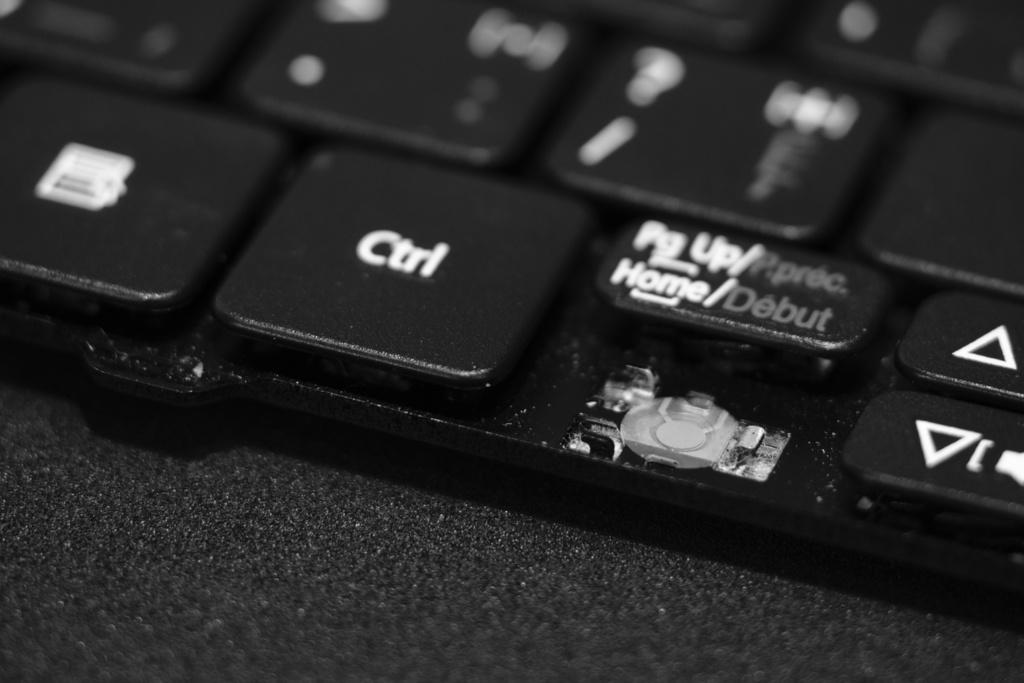<image>
Provide a brief description of the given image. a keyboard showing the key 'ctrl' at the bottom 